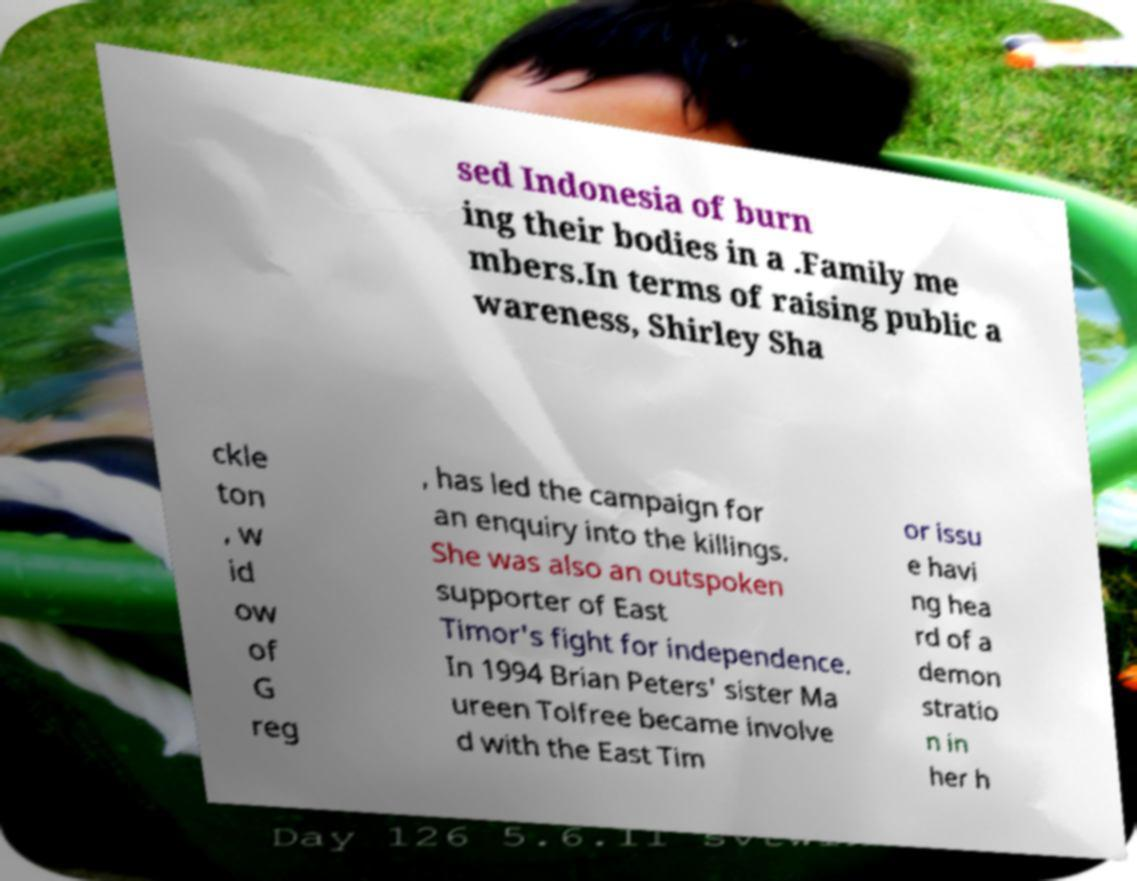There's text embedded in this image that I need extracted. Can you transcribe it verbatim? sed Indonesia of burn ing their bodies in a .Family me mbers.In terms of raising public a wareness, Shirley Sha ckle ton , w id ow of G reg , has led the campaign for an enquiry into the killings. She was also an outspoken supporter of East Timor's fight for independence. In 1994 Brian Peters' sister Ma ureen Tolfree became involve d with the East Tim or issu e havi ng hea rd of a demon stratio n in her h 